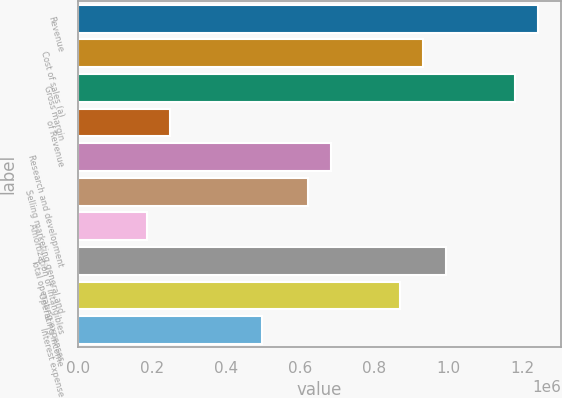<chart> <loc_0><loc_0><loc_500><loc_500><bar_chart><fcel>Revenue<fcel>Cost of sales (a)<fcel>Gross margin<fcel>of Revenue<fcel>Research and development<fcel>Selling marketing general and<fcel>Amortization of intangibles<fcel>Total operating expenses<fcel>Operating income<fcel>Interest expense<nl><fcel>1.24427e+06<fcel>933201<fcel>1.18205e+06<fcel>248854<fcel>684347<fcel>622134<fcel>186640<fcel>995414<fcel>870987<fcel>497707<nl></chart> 